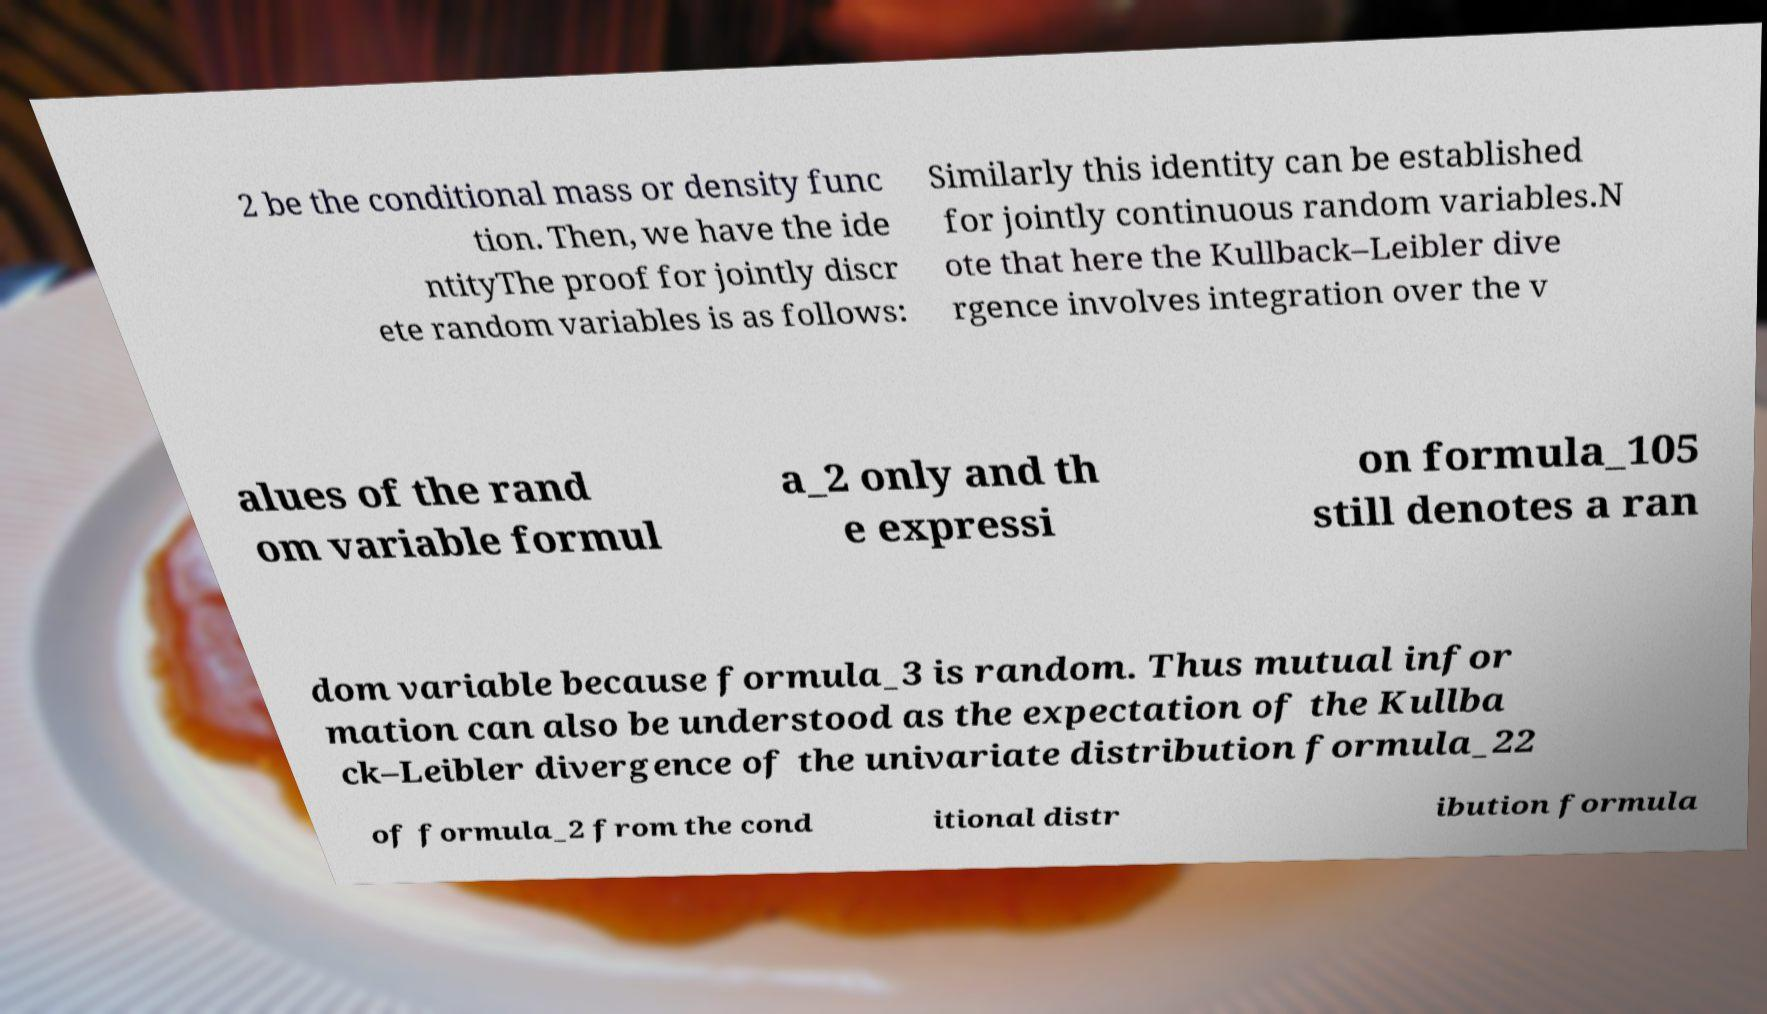Please identify and transcribe the text found in this image. 2 be the conditional mass or density func tion. Then, we have the ide ntityThe proof for jointly discr ete random variables is as follows: Similarly this identity can be established for jointly continuous random variables.N ote that here the Kullback–Leibler dive rgence involves integration over the v alues of the rand om variable formul a_2 only and th e expressi on formula_105 still denotes a ran dom variable because formula_3 is random. Thus mutual infor mation can also be understood as the expectation of the Kullba ck–Leibler divergence of the univariate distribution formula_22 of formula_2 from the cond itional distr ibution formula 